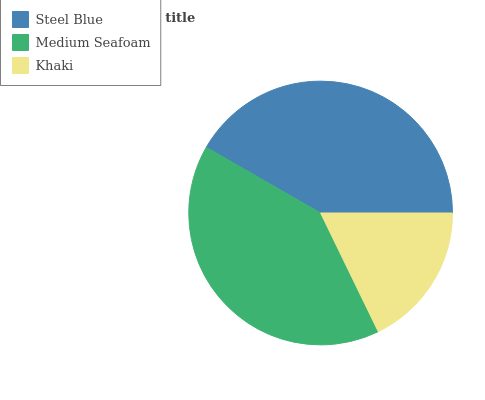Is Khaki the minimum?
Answer yes or no. Yes. Is Steel Blue the maximum?
Answer yes or no. Yes. Is Medium Seafoam the minimum?
Answer yes or no. No. Is Medium Seafoam the maximum?
Answer yes or no. No. Is Steel Blue greater than Medium Seafoam?
Answer yes or no. Yes. Is Medium Seafoam less than Steel Blue?
Answer yes or no. Yes. Is Medium Seafoam greater than Steel Blue?
Answer yes or no. No. Is Steel Blue less than Medium Seafoam?
Answer yes or no. No. Is Medium Seafoam the high median?
Answer yes or no. Yes. Is Medium Seafoam the low median?
Answer yes or no. Yes. Is Khaki the high median?
Answer yes or no. No. Is Steel Blue the low median?
Answer yes or no. No. 